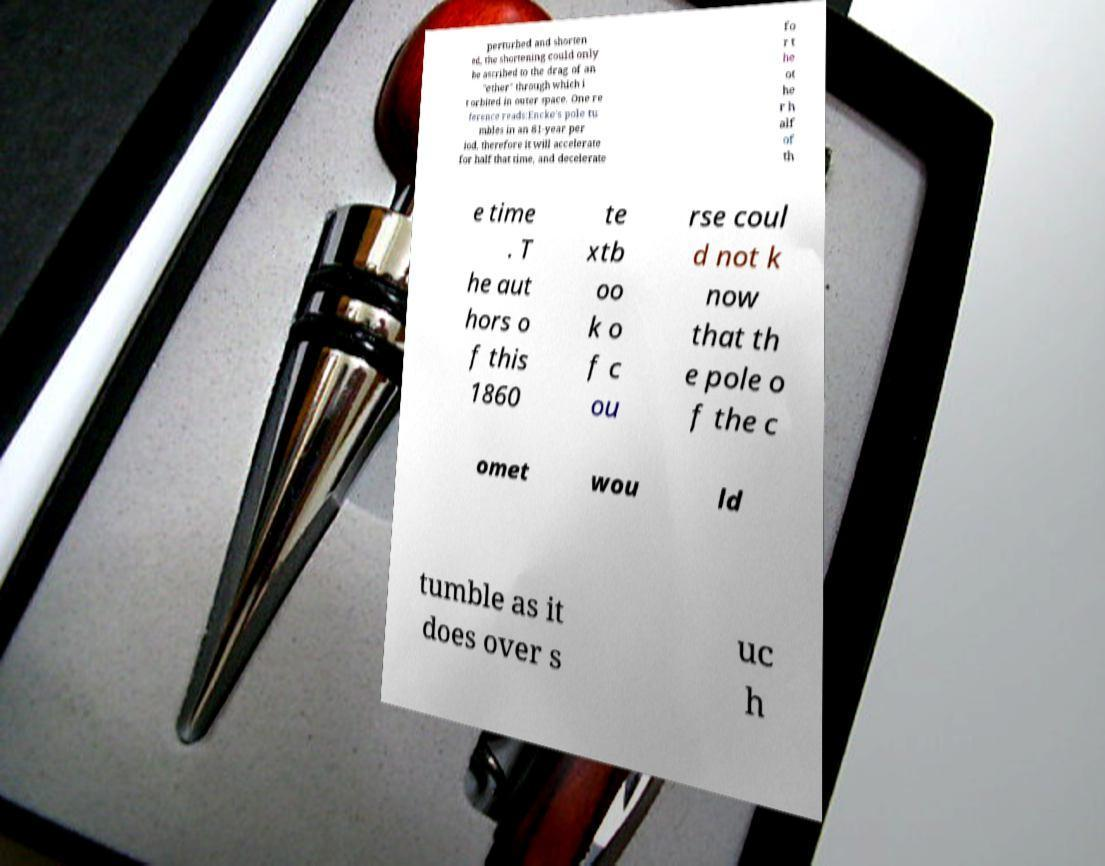What messages or text are displayed in this image? I need them in a readable, typed format. perturbed and shorten ed, the shortening could only be ascribed to the drag of an "ether" through which i t orbited in outer space. One re ference reads:Encke's pole tu mbles in an 81-year per iod, therefore it will accelerate for half that time, and decelerate fo r t he ot he r h alf of th e time . T he aut hors o f this 1860 te xtb oo k o f c ou rse coul d not k now that th e pole o f the c omet wou ld tumble as it does over s uc h 